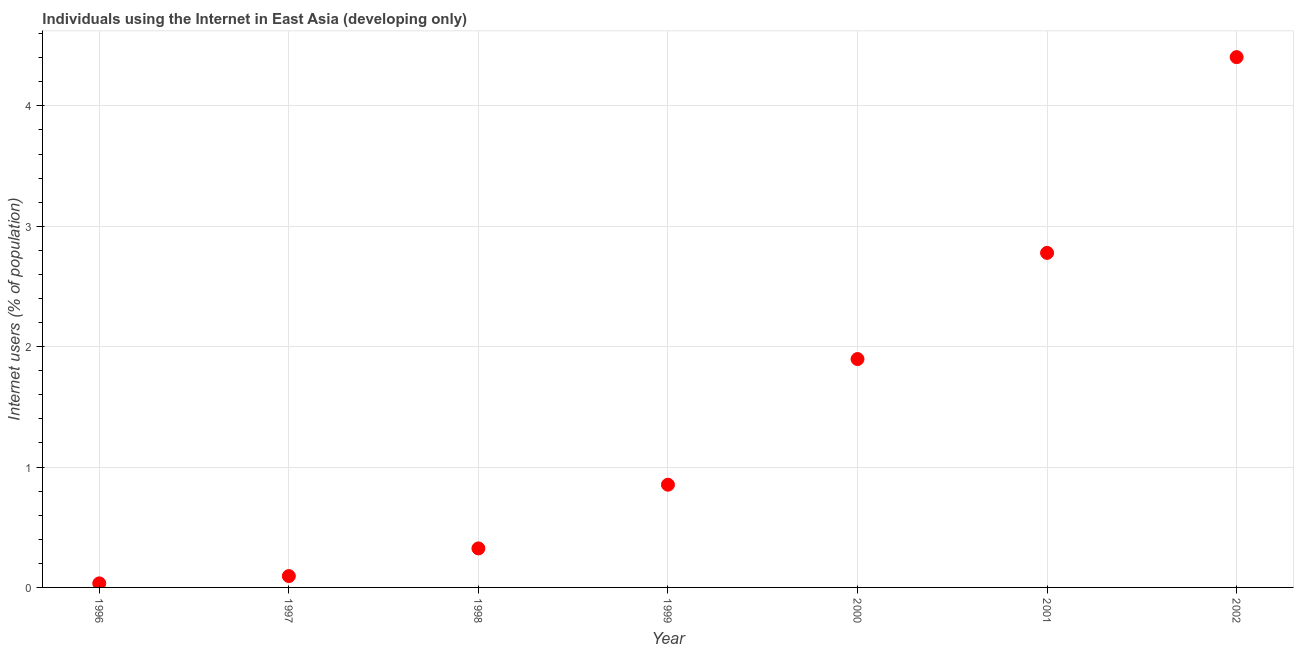What is the number of internet users in 2000?
Offer a terse response. 1.9. Across all years, what is the maximum number of internet users?
Your answer should be compact. 4.41. Across all years, what is the minimum number of internet users?
Your answer should be very brief. 0.03. In which year was the number of internet users minimum?
Ensure brevity in your answer.  1996. What is the sum of the number of internet users?
Ensure brevity in your answer.  10.39. What is the difference between the number of internet users in 1996 and 2002?
Your response must be concise. -4.37. What is the average number of internet users per year?
Your response must be concise. 1.48. What is the median number of internet users?
Your response must be concise. 0.85. In how many years, is the number of internet users greater than 1.4 %?
Your response must be concise. 3. Do a majority of the years between 2001 and 2000 (inclusive) have number of internet users greater than 3.4 %?
Offer a very short reply. No. What is the ratio of the number of internet users in 1999 to that in 2001?
Your response must be concise. 0.31. Is the difference between the number of internet users in 1998 and 2001 greater than the difference between any two years?
Offer a terse response. No. What is the difference between the highest and the second highest number of internet users?
Your answer should be very brief. 1.63. What is the difference between the highest and the lowest number of internet users?
Give a very brief answer. 4.37. In how many years, is the number of internet users greater than the average number of internet users taken over all years?
Give a very brief answer. 3. How many dotlines are there?
Provide a short and direct response. 1. How many years are there in the graph?
Your answer should be compact. 7. Are the values on the major ticks of Y-axis written in scientific E-notation?
Your response must be concise. No. Does the graph contain any zero values?
Provide a short and direct response. No. What is the title of the graph?
Ensure brevity in your answer.  Individuals using the Internet in East Asia (developing only). What is the label or title of the X-axis?
Your response must be concise. Year. What is the label or title of the Y-axis?
Give a very brief answer. Internet users (% of population). What is the Internet users (% of population) in 1996?
Provide a succinct answer. 0.03. What is the Internet users (% of population) in 1997?
Keep it short and to the point. 0.09. What is the Internet users (% of population) in 1998?
Ensure brevity in your answer.  0.32. What is the Internet users (% of population) in 1999?
Give a very brief answer. 0.85. What is the Internet users (% of population) in 2000?
Give a very brief answer. 1.9. What is the Internet users (% of population) in 2001?
Ensure brevity in your answer.  2.78. What is the Internet users (% of population) in 2002?
Keep it short and to the point. 4.41. What is the difference between the Internet users (% of population) in 1996 and 1997?
Give a very brief answer. -0.06. What is the difference between the Internet users (% of population) in 1996 and 1998?
Offer a very short reply. -0.29. What is the difference between the Internet users (% of population) in 1996 and 1999?
Keep it short and to the point. -0.82. What is the difference between the Internet users (% of population) in 1996 and 2000?
Offer a terse response. -1.86. What is the difference between the Internet users (% of population) in 1996 and 2001?
Ensure brevity in your answer.  -2.75. What is the difference between the Internet users (% of population) in 1996 and 2002?
Give a very brief answer. -4.37. What is the difference between the Internet users (% of population) in 1997 and 1998?
Keep it short and to the point. -0.23. What is the difference between the Internet users (% of population) in 1997 and 1999?
Provide a succinct answer. -0.76. What is the difference between the Internet users (% of population) in 1997 and 2000?
Offer a terse response. -1.8. What is the difference between the Internet users (% of population) in 1997 and 2001?
Provide a succinct answer. -2.68. What is the difference between the Internet users (% of population) in 1997 and 2002?
Provide a short and direct response. -4.31. What is the difference between the Internet users (% of population) in 1998 and 1999?
Give a very brief answer. -0.53. What is the difference between the Internet users (% of population) in 1998 and 2000?
Your answer should be compact. -1.57. What is the difference between the Internet users (% of population) in 1998 and 2001?
Your answer should be very brief. -2.45. What is the difference between the Internet users (% of population) in 1998 and 2002?
Provide a short and direct response. -4.08. What is the difference between the Internet users (% of population) in 1999 and 2000?
Your response must be concise. -1.04. What is the difference between the Internet users (% of population) in 1999 and 2001?
Your answer should be compact. -1.93. What is the difference between the Internet users (% of population) in 1999 and 2002?
Your response must be concise. -3.55. What is the difference between the Internet users (% of population) in 2000 and 2001?
Your answer should be very brief. -0.88. What is the difference between the Internet users (% of population) in 2000 and 2002?
Give a very brief answer. -2.51. What is the difference between the Internet users (% of population) in 2001 and 2002?
Your answer should be very brief. -1.63. What is the ratio of the Internet users (% of population) in 1996 to that in 1997?
Make the answer very short. 0.36. What is the ratio of the Internet users (% of population) in 1996 to that in 1998?
Ensure brevity in your answer.  0.1. What is the ratio of the Internet users (% of population) in 1996 to that in 1999?
Offer a very short reply. 0.04. What is the ratio of the Internet users (% of population) in 1996 to that in 2000?
Your answer should be compact. 0.02. What is the ratio of the Internet users (% of population) in 1996 to that in 2001?
Ensure brevity in your answer.  0.01. What is the ratio of the Internet users (% of population) in 1996 to that in 2002?
Your answer should be very brief. 0.01. What is the ratio of the Internet users (% of population) in 1997 to that in 1998?
Provide a short and direct response. 0.29. What is the ratio of the Internet users (% of population) in 1997 to that in 1999?
Make the answer very short. 0.11. What is the ratio of the Internet users (% of population) in 1997 to that in 2001?
Give a very brief answer. 0.03. What is the ratio of the Internet users (% of population) in 1997 to that in 2002?
Give a very brief answer. 0.02. What is the ratio of the Internet users (% of population) in 1998 to that in 1999?
Your answer should be very brief. 0.38. What is the ratio of the Internet users (% of population) in 1998 to that in 2000?
Your answer should be very brief. 0.17. What is the ratio of the Internet users (% of population) in 1998 to that in 2001?
Offer a very short reply. 0.12. What is the ratio of the Internet users (% of population) in 1998 to that in 2002?
Give a very brief answer. 0.07. What is the ratio of the Internet users (% of population) in 1999 to that in 2000?
Keep it short and to the point. 0.45. What is the ratio of the Internet users (% of population) in 1999 to that in 2001?
Give a very brief answer. 0.31. What is the ratio of the Internet users (% of population) in 1999 to that in 2002?
Your response must be concise. 0.19. What is the ratio of the Internet users (% of population) in 2000 to that in 2001?
Your response must be concise. 0.68. What is the ratio of the Internet users (% of population) in 2000 to that in 2002?
Give a very brief answer. 0.43. What is the ratio of the Internet users (% of population) in 2001 to that in 2002?
Offer a terse response. 0.63. 